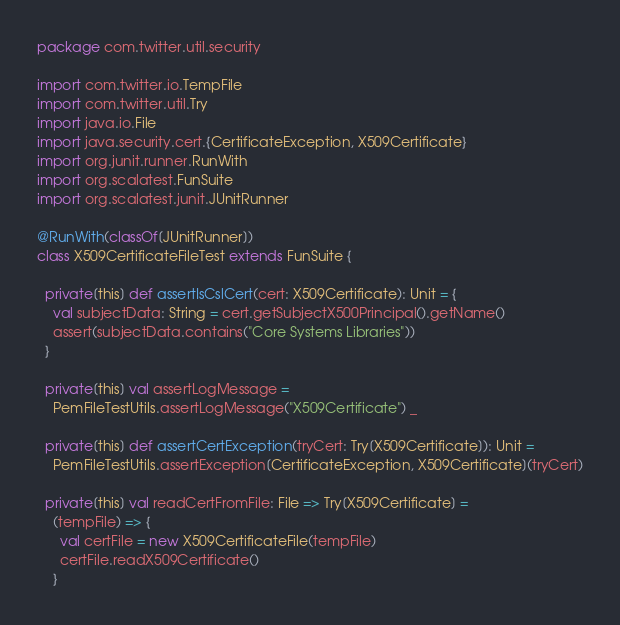<code> <loc_0><loc_0><loc_500><loc_500><_Scala_>package com.twitter.util.security

import com.twitter.io.TempFile
import com.twitter.util.Try
import java.io.File
import java.security.cert.{CertificateException, X509Certificate}
import org.junit.runner.RunWith
import org.scalatest.FunSuite
import org.scalatest.junit.JUnitRunner

@RunWith(classOf[JUnitRunner])
class X509CertificateFileTest extends FunSuite {

  private[this] def assertIsCslCert(cert: X509Certificate): Unit = {
    val subjectData: String = cert.getSubjectX500Principal().getName()
    assert(subjectData.contains("Core Systems Libraries"))
  }

  private[this] val assertLogMessage =
    PemFileTestUtils.assertLogMessage("X509Certificate") _

  private[this] def assertCertException(tryCert: Try[X509Certificate]): Unit =
    PemFileTestUtils.assertException[CertificateException, X509Certificate](tryCert)

  private[this] val readCertFromFile: File => Try[X509Certificate] =
    (tempFile) => {
      val certFile = new X509CertificateFile(tempFile)
      certFile.readX509Certificate()
    }
</code> 